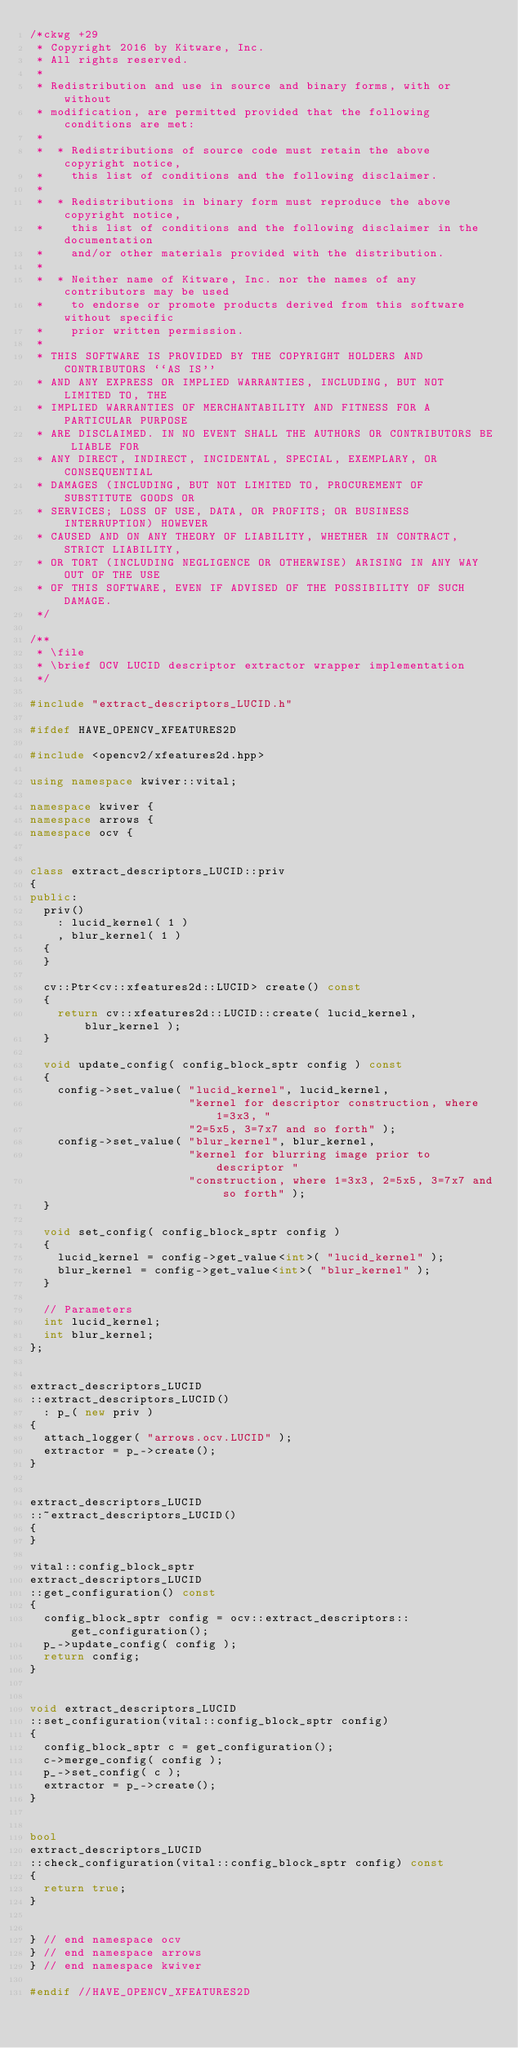<code> <loc_0><loc_0><loc_500><loc_500><_C++_>/*ckwg +29
 * Copyright 2016 by Kitware, Inc.
 * All rights reserved.
 *
 * Redistribution and use in source and binary forms, with or without
 * modification, are permitted provided that the following conditions are met:
 *
 *  * Redistributions of source code must retain the above copyright notice,
 *    this list of conditions and the following disclaimer.
 *
 *  * Redistributions in binary form must reproduce the above copyright notice,
 *    this list of conditions and the following disclaimer in the documentation
 *    and/or other materials provided with the distribution.
 *
 *  * Neither name of Kitware, Inc. nor the names of any contributors may be used
 *    to endorse or promote products derived from this software without specific
 *    prior written permission.
 *
 * THIS SOFTWARE IS PROVIDED BY THE COPYRIGHT HOLDERS AND CONTRIBUTORS ``AS IS''
 * AND ANY EXPRESS OR IMPLIED WARRANTIES, INCLUDING, BUT NOT LIMITED TO, THE
 * IMPLIED WARRANTIES OF MERCHANTABILITY AND FITNESS FOR A PARTICULAR PURPOSE
 * ARE DISCLAIMED. IN NO EVENT SHALL THE AUTHORS OR CONTRIBUTORS BE LIABLE FOR
 * ANY DIRECT, INDIRECT, INCIDENTAL, SPECIAL, EXEMPLARY, OR CONSEQUENTIAL
 * DAMAGES (INCLUDING, BUT NOT LIMITED TO, PROCUREMENT OF SUBSTITUTE GOODS OR
 * SERVICES; LOSS OF USE, DATA, OR PROFITS; OR BUSINESS INTERRUPTION) HOWEVER
 * CAUSED AND ON ANY THEORY OF LIABILITY, WHETHER IN CONTRACT, STRICT LIABILITY,
 * OR TORT (INCLUDING NEGLIGENCE OR OTHERWISE) ARISING IN ANY WAY OUT OF THE USE
 * OF THIS SOFTWARE, EVEN IF ADVISED OF THE POSSIBILITY OF SUCH DAMAGE.
 */

/**
 * \file
 * \brief OCV LUCID descriptor extractor wrapper implementation
 */

#include "extract_descriptors_LUCID.h"

#ifdef HAVE_OPENCV_XFEATURES2D

#include <opencv2/xfeatures2d.hpp>

using namespace kwiver::vital;

namespace kwiver {
namespace arrows {
namespace ocv {


class extract_descriptors_LUCID::priv
{
public:
  priv()
    : lucid_kernel( 1 )
    , blur_kernel( 1 )
  {
  }

  cv::Ptr<cv::xfeatures2d::LUCID> create() const
  {
    return cv::xfeatures2d::LUCID::create( lucid_kernel, blur_kernel );
  }

  void update_config( config_block_sptr config ) const
  {
    config->set_value( "lucid_kernel", lucid_kernel,
                       "kernel for descriptor construction, where 1=3x3, "
                       "2=5x5, 3=7x7 and so forth" );
    config->set_value( "blur_kernel", blur_kernel,
                       "kernel for blurring image prior to descriptor "
                       "construction, where 1=3x3, 2=5x5, 3=7x7 and so forth" );
  }

  void set_config( config_block_sptr config )
  {
    lucid_kernel = config->get_value<int>( "lucid_kernel" );
    blur_kernel = config->get_value<int>( "blur_kernel" );
  }

  // Parameters
  int lucid_kernel;
  int blur_kernel;
};


extract_descriptors_LUCID
::extract_descriptors_LUCID()
  : p_( new priv )
{
  attach_logger( "arrows.ocv.LUCID" );
  extractor = p_->create();
}


extract_descriptors_LUCID
::~extract_descriptors_LUCID()
{
}

vital::config_block_sptr
extract_descriptors_LUCID
::get_configuration() const
{
  config_block_sptr config = ocv::extract_descriptors::get_configuration();
  p_->update_config( config );
  return config;
}


void extract_descriptors_LUCID
::set_configuration(vital::config_block_sptr config)
{
  config_block_sptr c = get_configuration();
  c->merge_config( config );
  p_->set_config( c );
  extractor = p_->create();
}


bool
extract_descriptors_LUCID
::check_configuration(vital::config_block_sptr config) const
{
  return true;
}


} // end namespace ocv
} // end namespace arrows
} // end namespace kwiver

#endif //HAVE_OPENCV_XFEATURES2D
</code> 